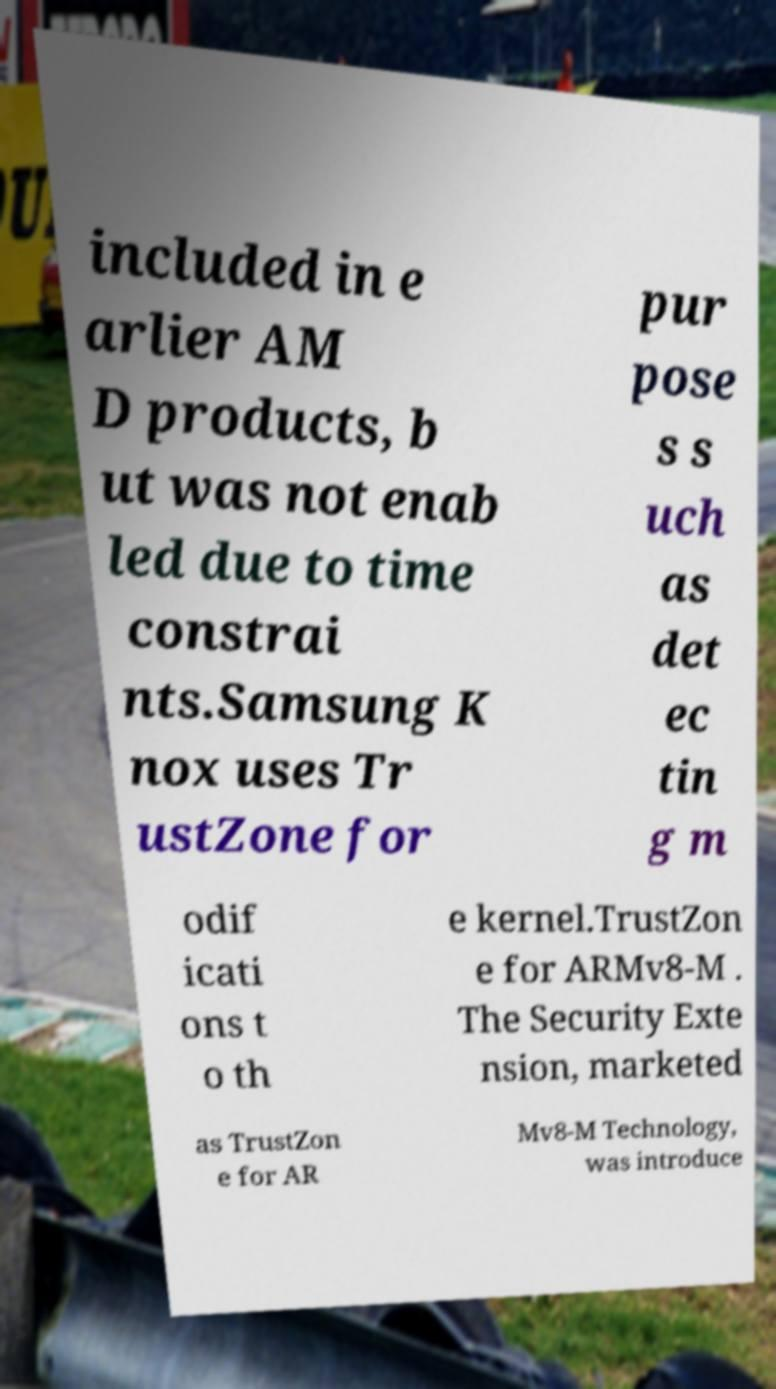For documentation purposes, I need the text within this image transcribed. Could you provide that? included in e arlier AM D products, b ut was not enab led due to time constrai nts.Samsung K nox uses Tr ustZone for pur pose s s uch as det ec tin g m odif icati ons t o th e kernel.TrustZon e for ARMv8-M . The Security Exte nsion, marketed as TrustZon e for AR Mv8-M Technology, was introduce 